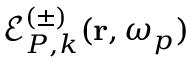Convert formula to latex. <formula><loc_0><loc_0><loc_500><loc_500>\mathcal { E } _ { P , k } ^ { ( \pm ) } ( r , \omega _ { p } )</formula> 